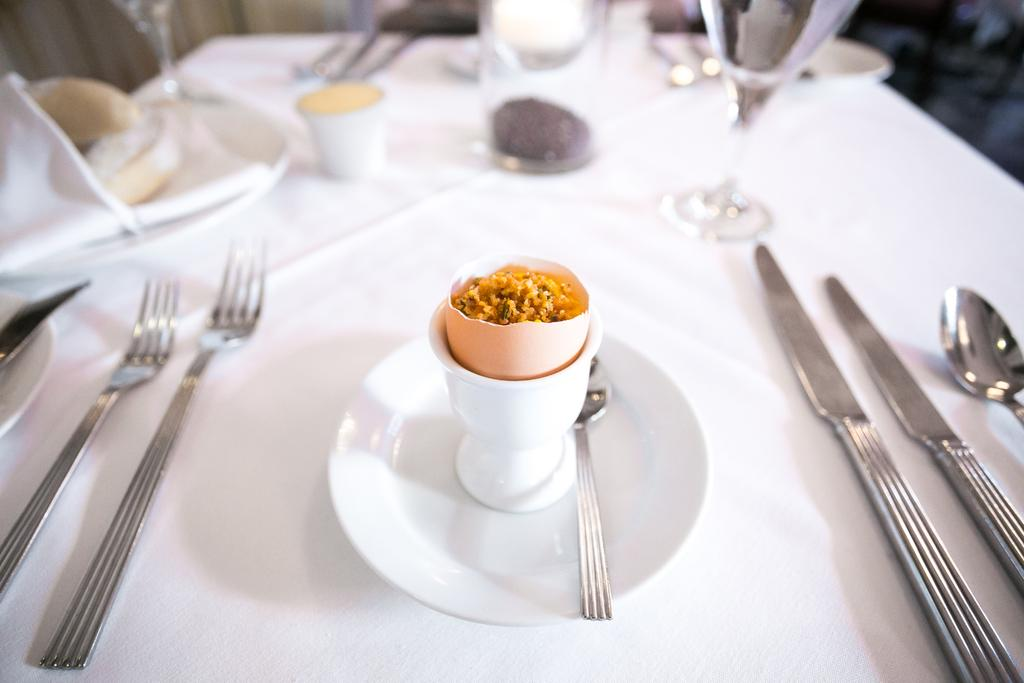What type of furniture is present in the image? There is a table in the image. What items can be seen on the table? There are plates, forks, spoons, knives, cups, and food items on the table. How many different types of utensils are on the table? There are four different types of utensils on the table: forks, spoons, knives, and cups. What type of pets are visible on the table in the image? There are no pets visible on the table in the image. What color is the skirt worn by the person sitting at the table? There is no person sitting at the table in the image, and therefore no skirt to describe. 